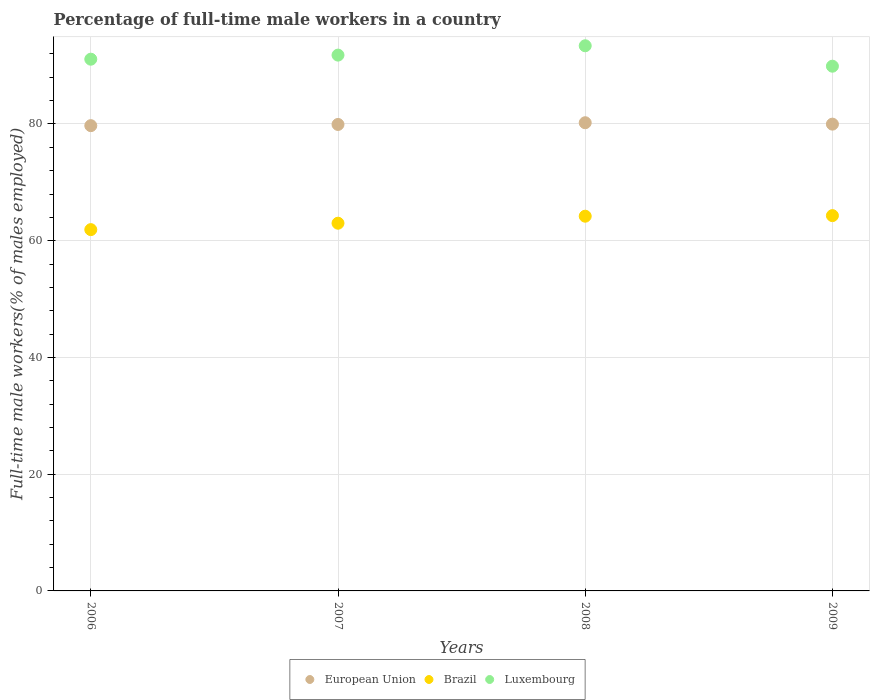Is the number of dotlines equal to the number of legend labels?
Keep it short and to the point. Yes. What is the percentage of full-time male workers in Luxembourg in 2007?
Give a very brief answer. 91.8. Across all years, what is the maximum percentage of full-time male workers in Luxembourg?
Your answer should be compact. 93.4. Across all years, what is the minimum percentage of full-time male workers in Brazil?
Provide a succinct answer. 61.9. In which year was the percentage of full-time male workers in Brazil minimum?
Provide a succinct answer. 2006. What is the total percentage of full-time male workers in Brazil in the graph?
Your answer should be very brief. 253.4. What is the difference between the percentage of full-time male workers in Luxembourg in 2007 and that in 2008?
Your response must be concise. -1.6. What is the difference between the percentage of full-time male workers in European Union in 2007 and the percentage of full-time male workers in Brazil in 2009?
Make the answer very short. 15.62. What is the average percentage of full-time male workers in Brazil per year?
Give a very brief answer. 63.35. In the year 2009, what is the difference between the percentage of full-time male workers in European Union and percentage of full-time male workers in Luxembourg?
Make the answer very short. -9.93. What is the ratio of the percentage of full-time male workers in Brazil in 2007 to that in 2009?
Provide a succinct answer. 0.98. Is the percentage of full-time male workers in Luxembourg in 2006 less than that in 2009?
Offer a terse response. No. Is the difference between the percentage of full-time male workers in European Union in 2007 and 2009 greater than the difference between the percentage of full-time male workers in Luxembourg in 2007 and 2009?
Provide a short and direct response. No. What is the difference between the highest and the second highest percentage of full-time male workers in Brazil?
Keep it short and to the point. 0.1. Does the percentage of full-time male workers in Luxembourg monotonically increase over the years?
Make the answer very short. No. How many years are there in the graph?
Make the answer very short. 4. What is the difference between two consecutive major ticks on the Y-axis?
Give a very brief answer. 20. Are the values on the major ticks of Y-axis written in scientific E-notation?
Offer a terse response. No. Does the graph contain grids?
Keep it short and to the point. Yes. What is the title of the graph?
Keep it short and to the point. Percentage of full-time male workers in a country. What is the label or title of the Y-axis?
Ensure brevity in your answer.  Full-time male workers(% of males employed). What is the Full-time male workers(% of males employed) in European Union in 2006?
Your answer should be very brief. 79.71. What is the Full-time male workers(% of males employed) in Brazil in 2006?
Your answer should be compact. 61.9. What is the Full-time male workers(% of males employed) of Luxembourg in 2006?
Make the answer very short. 91.1. What is the Full-time male workers(% of males employed) of European Union in 2007?
Offer a very short reply. 79.92. What is the Full-time male workers(% of males employed) of Luxembourg in 2007?
Provide a short and direct response. 91.8. What is the Full-time male workers(% of males employed) of European Union in 2008?
Make the answer very short. 80.21. What is the Full-time male workers(% of males employed) in Brazil in 2008?
Provide a succinct answer. 64.2. What is the Full-time male workers(% of males employed) of Luxembourg in 2008?
Provide a succinct answer. 93.4. What is the Full-time male workers(% of males employed) of European Union in 2009?
Give a very brief answer. 79.97. What is the Full-time male workers(% of males employed) of Brazil in 2009?
Offer a very short reply. 64.3. What is the Full-time male workers(% of males employed) in Luxembourg in 2009?
Provide a short and direct response. 89.9. Across all years, what is the maximum Full-time male workers(% of males employed) of European Union?
Provide a succinct answer. 80.21. Across all years, what is the maximum Full-time male workers(% of males employed) of Brazil?
Offer a terse response. 64.3. Across all years, what is the maximum Full-time male workers(% of males employed) in Luxembourg?
Your answer should be very brief. 93.4. Across all years, what is the minimum Full-time male workers(% of males employed) in European Union?
Offer a terse response. 79.71. Across all years, what is the minimum Full-time male workers(% of males employed) in Brazil?
Offer a terse response. 61.9. Across all years, what is the minimum Full-time male workers(% of males employed) of Luxembourg?
Keep it short and to the point. 89.9. What is the total Full-time male workers(% of males employed) of European Union in the graph?
Provide a succinct answer. 319.82. What is the total Full-time male workers(% of males employed) in Brazil in the graph?
Offer a terse response. 253.4. What is the total Full-time male workers(% of males employed) in Luxembourg in the graph?
Offer a terse response. 366.2. What is the difference between the Full-time male workers(% of males employed) in European Union in 2006 and that in 2007?
Your response must be concise. -0.21. What is the difference between the Full-time male workers(% of males employed) of European Union in 2006 and that in 2008?
Your answer should be compact. -0.5. What is the difference between the Full-time male workers(% of males employed) of Brazil in 2006 and that in 2008?
Offer a very short reply. -2.3. What is the difference between the Full-time male workers(% of males employed) in European Union in 2006 and that in 2009?
Ensure brevity in your answer.  -0.26. What is the difference between the Full-time male workers(% of males employed) in Luxembourg in 2006 and that in 2009?
Offer a very short reply. 1.2. What is the difference between the Full-time male workers(% of males employed) of European Union in 2007 and that in 2008?
Offer a terse response. -0.3. What is the difference between the Full-time male workers(% of males employed) in Luxembourg in 2007 and that in 2008?
Offer a terse response. -1.6. What is the difference between the Full-time male workers(% of males employed) of European Union in 2007 and that in 2009?
Your response must be concise. -0.05. What is the difference between the Full-time male workers(% of males employed) in European Union in 2008 and that in 2009?
Ensure brevity in your answer.  0.24. What is the difference between the Full-time male workers(% of males employed) of European Union in 2006 and the Full-time male workers(% of males employed) of Brazil in 2007?
Provide a succinct answer. 16.71. What is the difference between the Full-time male workers(% of males employed) of European Union in 2006 and the Full-time male workers(% of males employed) of Luxembourg in 2007?
Offer a terse response. -12.09. What is the difference between the Full-time male workers(% of males employed) in Brazil in 2006 and the Full-time male workers(% of males employed) in Luxembourg in 2007?
Offer a terse response. -29.9. What is the difference between the Full-time male workers(% of males employed) in European Union in 2006 and the Full-time male workers(% of males employed) in Brazil in 2008?
Ensure brevity in your answer.  15.51. What is the difference between the Full-time male workers(% of males employed) of European Union in 2006 and the Full-time male workers(% of males employed) of Luxembourg in 2008?
Keep it short and to the point. -13.69. What is the difference between the Full-time male workers(% of males employed) of Brazil in 2006 and the Full-time male workers(% of males employed) of Luxembourg in 2008?
Offer a very short reply. -31.5. What is the difference between the Full-time male workers(% of males employed) of European Union in 2006 and the Full-time male workers(% of males employed) of Brazil in 2009?
Ensure brevity in your answer.  15.41. What is the difference between the Full-time male workers(% of males employed) in European Union in 2006 and the Full-time male workers(% of males employed) in Luxembourg in 2009?
Provide a short and direct response. -10.19. What is the difference between the Full-time male workers(% of males employed) in Brazil in 2006 and the Full-time male workers(% of males employed) in Luxembourg in 2009?
Provide a short and direct response. -28. What is the difference between the Full-time male workers(% of males employed) of European Union in 2007 and the Full-time male workers(% of males employed) of Brazil in 2008?
Your response must be concise. 15.72. What is the difference between the Full-time male workers(% of males employed) of European Union in 2007 and the Full-time male workers(% of males employed) of Luxembourg in 2008?
Offer a very short reply. -13.48. What is the difference between the Full-time male workers(% of males employed) in Brazil in 2007 and the Full-time male workers(% of males employed) in Luxembourg in 2008?
Keep it short and to the point. -30.4. What is the difference between the Full-time male workers(% of males employed) in European Union in 2007 and the Full-time male workers(% of males employed) in Brazil in 2009?
Provide a succinct answer. 15.62. What is the difference between the Full-time male workers(% of males employed) in European Union in 2007 and the Full-time male workers(% of males employed) in Luxembourg in 2009?
Provide a short and direct response. -9.98. What is the difference between the Full-time male workers(% of males employed) of Brazil in 2007 and the Full-time male workers(% of males employed) of Luxembourg in 2009?
Make the answer very short. -26.9. What is the difference between the Full-time male workers(% of males employed) of European Union in 2008 and the Full-time male workers(% of males employed) of Brazil in 2009?
Your answer should be compact. 15.91. What is the difference between the Full-time male workers(% of males employed) in European Union in 2008 and the Full-time male workers(% of males employed) in Luxembourg in 2009?
Your response must be concise. -9.69. What is the difference between the Full-time male workers(% of males employed) in Brazil in 2008 and the Full-time male workers(% of males employed) in Luxembourg in 2009?
Your answer should be compact. -25.7. What is the average Full-time male workers(% of males employed) of European Union per year?
Give a very brief answer. 79.95. What is the average Full-time male workers(% of males employed) in Brazil per year?
Provide a succinct answer. 63.35. What is the average Full-time male workers(% of males employed) of Luxembourg per year?
Ensure brevity in your answer.  91.55. In the year 2006, what is the difference between the Full-time male workers(% of males employed) of European Union and Full-time male workers(% of males employed) of Brazil?
Provide a succinct answer. 17.81. In the year 2006, what is the difference between the Full-time male workers(% of males employed) in European Union and Full-time male workers(% of males employed) in Luxembourg?
Keep it short and to the point. -11.39. In the year 2006, what is the difference between the Full-time male workers(% of males employed) of Brazil and Full-time male workers(% of males employed) of Luxembourg?
Provide a short and direct response. -29.2. In the year 2007, what is the difference between the Full-time male workers(% of males employed) of European Union and Full-time male workers(% of males employed) of Brazil?
Make the answer very short. 16.92. In the year 2007, what is the difference between the Full-time male workers(% of males employed) in European Union and Full-time male workers(% of males employed) in Luxembourg?
Your answer should be very brief. -11.88. In the year 2007, what is the difference between the Full-time male workers(% of males employed) in Brazil and Full-time male workers(% of males employed) in Luxembourg?
Make the answer very short. -28.8. In the year 2008, what is the difference between the Full-time male workers(% of males employed) of European Union and Full-time male workers(% of males employed) of Brazil?
Give a very brief answer. 16.01. In the year 2008, what is the difference between the Full-time male workers(% of males employed) of European Union and Full-time male workers(% of males employed) of Luxembourg?
Provide a succinct answer. -13.19. In the year 2008, what is the difference between the Full-time male workers(% of males employed) of Brazil and Full-time male workers(% of males employed) of Luxembourg?
Keep it short and to the point. -29.2. In the year 2009, what is the difference between the Full-time male workers(% of males employed) in European Union and Full-time male workers(% of males employed) in Brazil?
Offer a very short reply. 15.67. In the year 2009, what is the difference between the Full-time male workers(% of males employed) in European Union and Full-time male workers(% of males employed) in Luxembourg?
Make the answer very short. -9.93. In the year 2009, what is the difference between the Full-time male workers(% of males employed) of Brazil and Full-time male workers(% of males employed) of Luxembourg?
Provide a succinct answer. -25.6. What is the ratio of the Full-time male workers(% of males employed) of Brazil in 2006 to that in 2007?
Provide a short and direct response. 0.98. What is the ratio of the Full-time male workers(% of males employed) of Brazil in 2006 to that in 2008?
Provide a short and direct response. 0.96. What is the ratio of the Full-time male workers(% of males employed) of Luxembourg in 2006 to that in 2008?
Make the answer very short. 0.98. What is the ratio of the Full-time male workers(% of males employed) in European Union in 2006 to that in 2009?
Ensure brevity in your answer.  1. What is the ratio of the Full-time male workers(% of males employed) of Brazil in 2006 to that in 2009?
Your answer should be compact. 0.96. What is the ratio of the Full-time male workers(% of males employed) in Luxembourg in 2006 to that in 2009?
Give a very brief answer. 1.01. What is the ratio of the Full-time male workers(% of males employed) of Brazil in 2007 to that in 2008?
Give a very brief answer. 0.98. What is the ratio of the Full-time male workers(% of males employed) in Luxembourg in 2007 to that in 2008?
Your answer should be compact. 0.98. What is the ratio of the Full-time male workers(% of males employed) in European Union in 2007 to that in 2009?
Your answer should be very brief. 1. What is the ratio of the Full-time male workers(% of males employed) of Brazil in 2007 to that in 2009?
Provide a short and direct response. 0.98. What is the ratio of the Full-time male workers(% of males employed) of Luxembourg in 2007 to that in 2009?
Make the answer very short. 1.02. What is the ratio of the Full-time male workers(% of males employed) in European Union in 2008 to that in 2009?
Your response must be concise. 1. What is the ratio of the Full-time male workers(% of males employed) in Brazil in 2008 to that in 2009?
Your response must be concise. 1. What is the ratio of the Full-time male workers(% of males employed) of Luxembourg in 2008 to that in 2009?
Make the answer very short. 1.04. What is the difference between the highest and the second highest Full-time male workers(% of males employed) of European Union?
Your answer should be very brief. 0.24. What is the difference between the highest and the second highest Full-time male workers(% of males employed) of Luxembourg?
Offer a terse response. 1.6. What is the difference between the highest and the lowest Full-time male workers(% of males employed) in European Union?
Your response must be concise. 0.5. What is the difference between the highest and the lowest Full-time male workers(% of males employed) of Brazil?
Your answer should be compact. 2.4. 